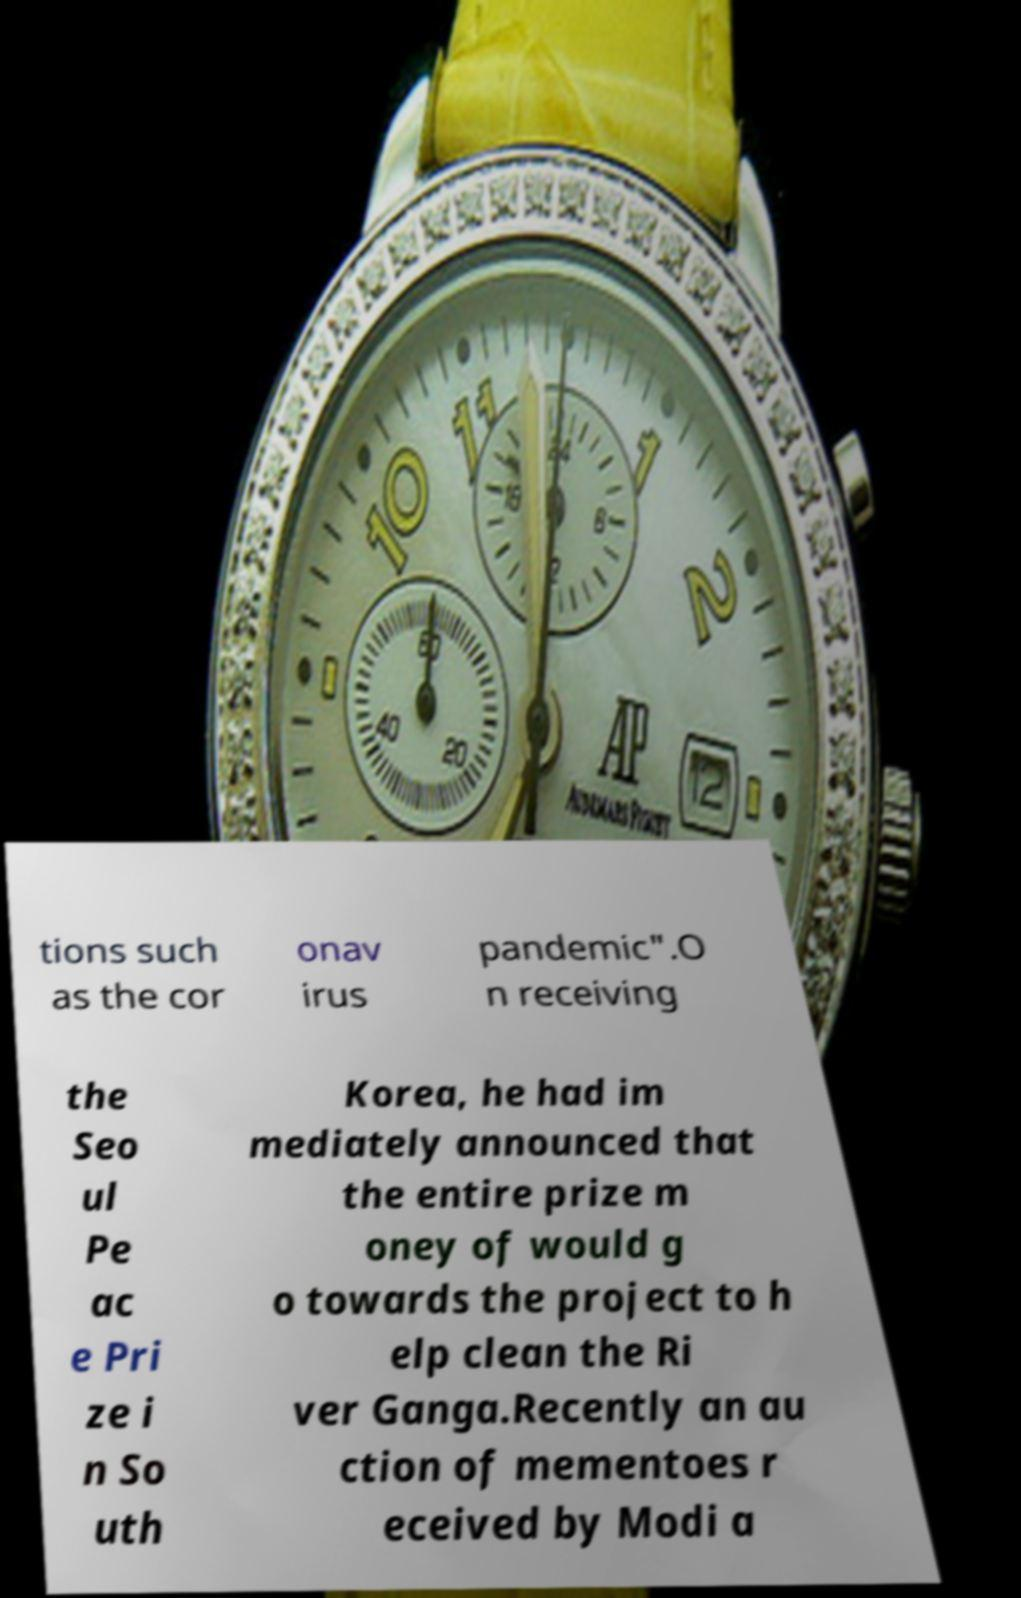Could you assist in decoding the text presented in this image and type it out clearly? tions such as the cor onav irus pandemic".O n receiving the Seo ul Pe ac e Pri ze i n So uth Korea, he had im mediately announced that the entire prize m oney of would g o towards the project to h elp clean the Ri ver Ganga.Recently an au ction of mementoes r eceived by Modi a 